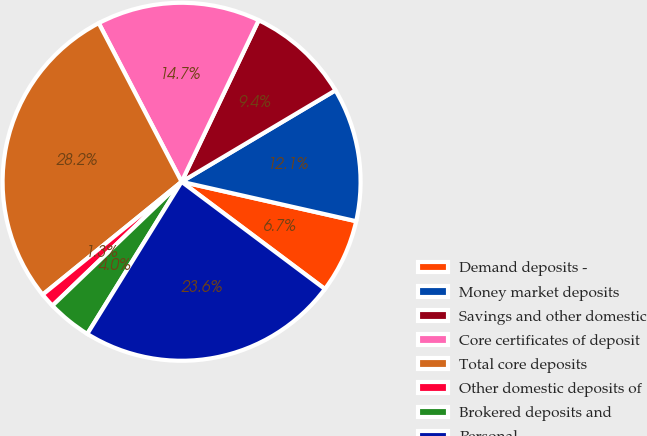Convert chart to OTSL. <chart><loc_0><loc_0><loc_500><loc_500><pie_chart><fcel>Demand deposits -<fcel>Money market deposits<fcel>Savings and other domestic<fcel>Core certificates of deposit<fcel>Total core deposits<fcel>Other domestic deposits of<fcel>Brokered deposits and<fcel>Personal<nl><fcel>6.69%<fcel>12.07%<fcel>9.38%<fcel>14.75%<fcel>28.2%<fcel>1.31%<fcel>4.0%<fcel>23.61%<nl></chart> 